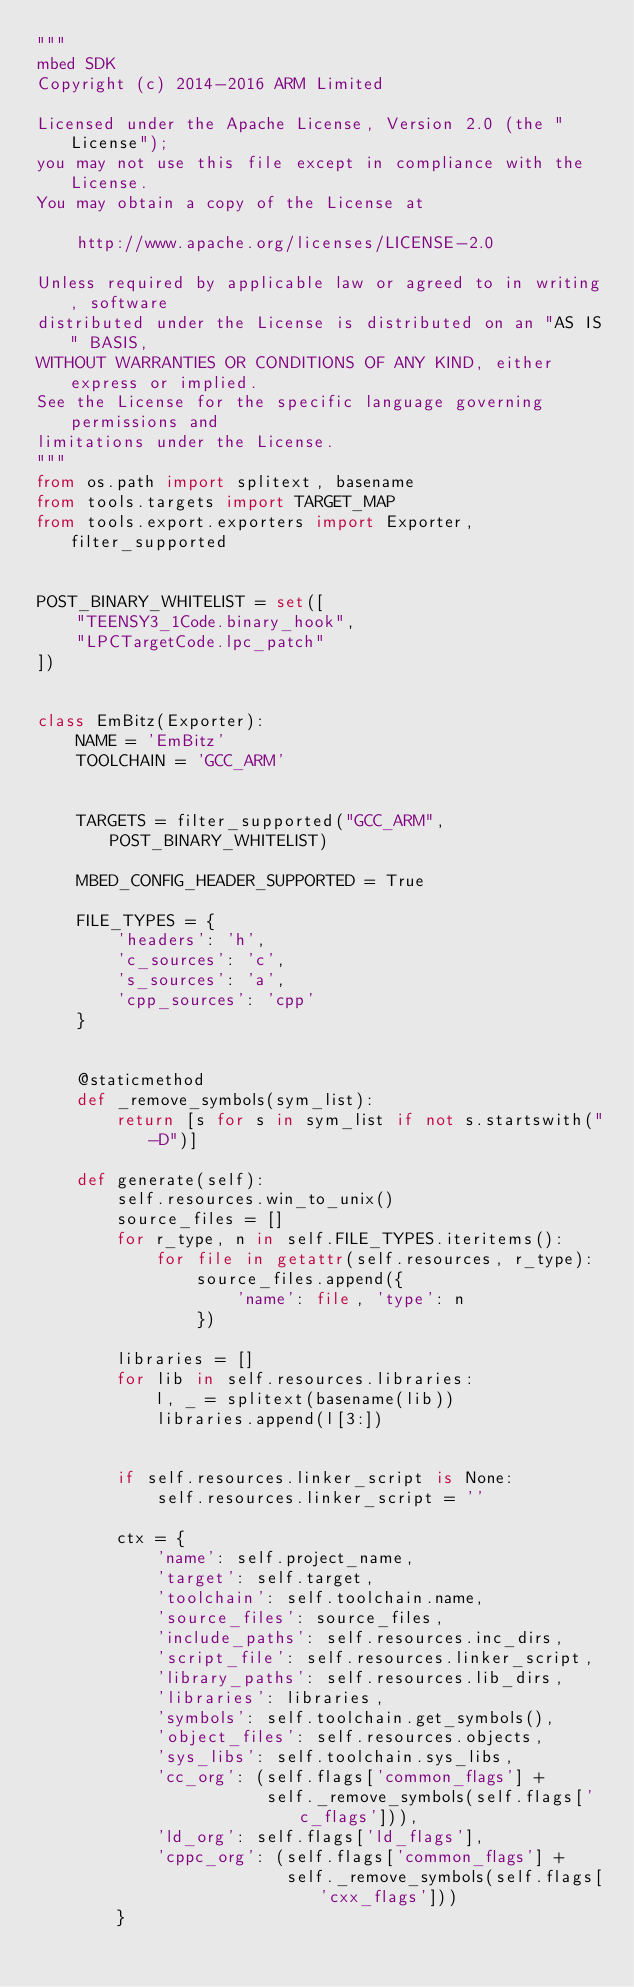<code> <loc_0><loc_0><loc_500><loc_500><_Python_>"""
mbed SDK
Copyright (c) 2014-2016 ARM Limited

Licensed under the Apache License, Version 2.0 (the "License");
you may not use this file except in compliance with the License.
You may obtain a copy of the License at

    http://www.apache.org/licenses/LICENSE-2.0

Unless required by applicable law or agreed to in writing, software
distributed under the License is distributed on an "AS IS" BASIS,
WITHOUT WARRANTIES OR CONDITIONS OF ANY KIND, either express or implied.
See the License for the specific language governing permissions and
limitations under the License.
"""
from os.path import splitext, basename
from tools.targets import TARGET_MAP
from tools.export.exporters import Exporter, filter_supported


POST_BINARY_WHITELIST = set([
    "TEENSY3_1Code.binary_hook",
    "LPCTargetCode.lpc_patch"
])


class EmBitz(Exporter):
    NAME = 'EmBitz'
    TOOLCHAIN = 'GCC_ARM'


    TARGETS = filter_supported("GCC_ARM", POST_BINARY_WHITELIST)

    MBED_CONFIG_HEADER_SUPPORTED = True

    FILE_TYPES = {
        'headers': 'h',
        'c_sources': 'c',
        's_sources': 'a',
        'cpp_sources': 'cpp'
    }


    @staticmethod
    def _remove_symbols(sym_list):
        return [s for s in sym_list if not s.startswith("-D")]

    def generate(self):
        self.resources.win_to_unix()
        source_files = []
        for r_type, n in self.FILE_TYPES.iteritems():
            for file in getattr(self.resources, r_type):
                source_files.append({
                    'name': file, 'type': n
                })

        libraries = []
        for lib in self.resources.libraries:
            l, _ = splitext(basename(lib))
            libraries.append(l[3:])


        if self.resources.linker_script is None:
            self.resources.linker_script = ''

        ctx = {
            'name': self.project_name,
            'target': self.target,
            'toolchain': self.toolchain.name,
            'source_files': source_files,
            'include_paths': self.resources.inc_dirs,
            'script_file': self.resources.linker_script,
            'library_paths': self.resources.lib_dirs,
            'libraries': libraries,
            'symbols': self.toolchain.get_symbols(),
            'object_files': self.resources.objects,
            'sys_libs': self.toolchain.sys_libs,
            'cc_org': (self.flags['common_flags'] +
                       self._remove_symbols(self.flags['c_flags'])),
            'ld_org': self.flags['ld_flags'],
            'cppc_org': (self.flags['common_flags'] +
                         self._remove_symbols(self.flags['cxx_flags']))
        }
</code> 